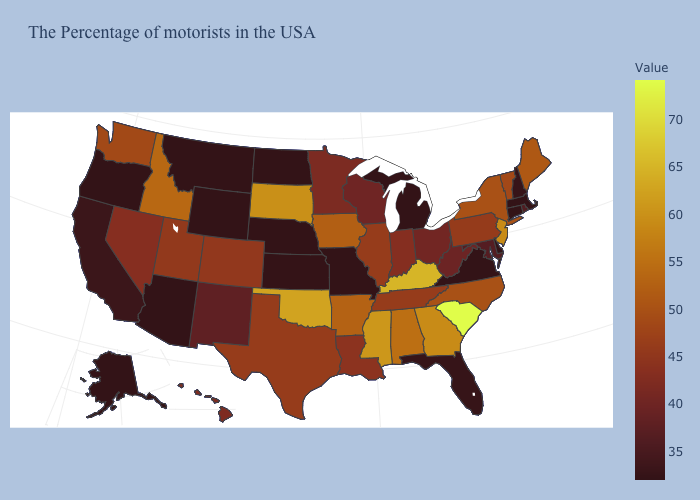Which states have the lowest value in the USA?
Keep it brief. Massachusetts, Connecticut, Delaware, Virginia, Michigan, Missouri, Nebraska, North Dakota, Wyoming, Montana, Arizona, Oregon, Alaska. Does Delaware have the lowest value in the USA?
Give a very brief answer. Yes. Is the legend a continuous bar?
Quick response, please. Yes. Does Utah have the lowest value in the West?
Give a very brief answer. No. 